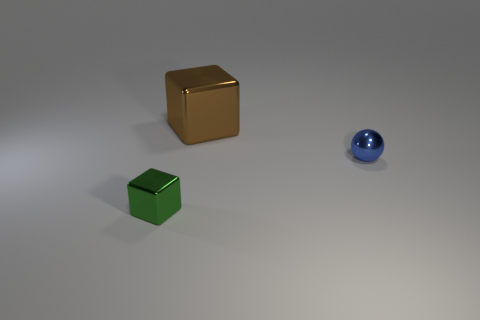Is there any other thing that is the same shape as the blue metal object?
Keep it short and to the point. No. Is the number of small shiny balls that are to the left of the blue shiny object greater than the number of large cubes?
Make the answer very short. No. Is the size of the green object the same as the blue metal ball?
Your answer should be very brief. Yes. What is the material of the small green thing that is the same shape as the large shiny thing?
Provide a succinct answer. Metal. How many yellow things are either tiny shiny things or shiny blocks?
Make the answer very short. 0. There is a tiny thing on the left side of the brown block; what is its material?
Offer a terse response. Metal. Are there more cyan metallic objects than small shiny balls?
Your answer should be very brief. No. Do the tiny blue shiny object that is to the right of the small green metal cube and the green object have the same shape?
Make the answer very short. No. How many metal objects are both left of the blue thing and in front of the brown metal object?
Offer a terse response. 1. How many other tiny things have the same shape as the brown object?
Keep it short and to the point. 1. 